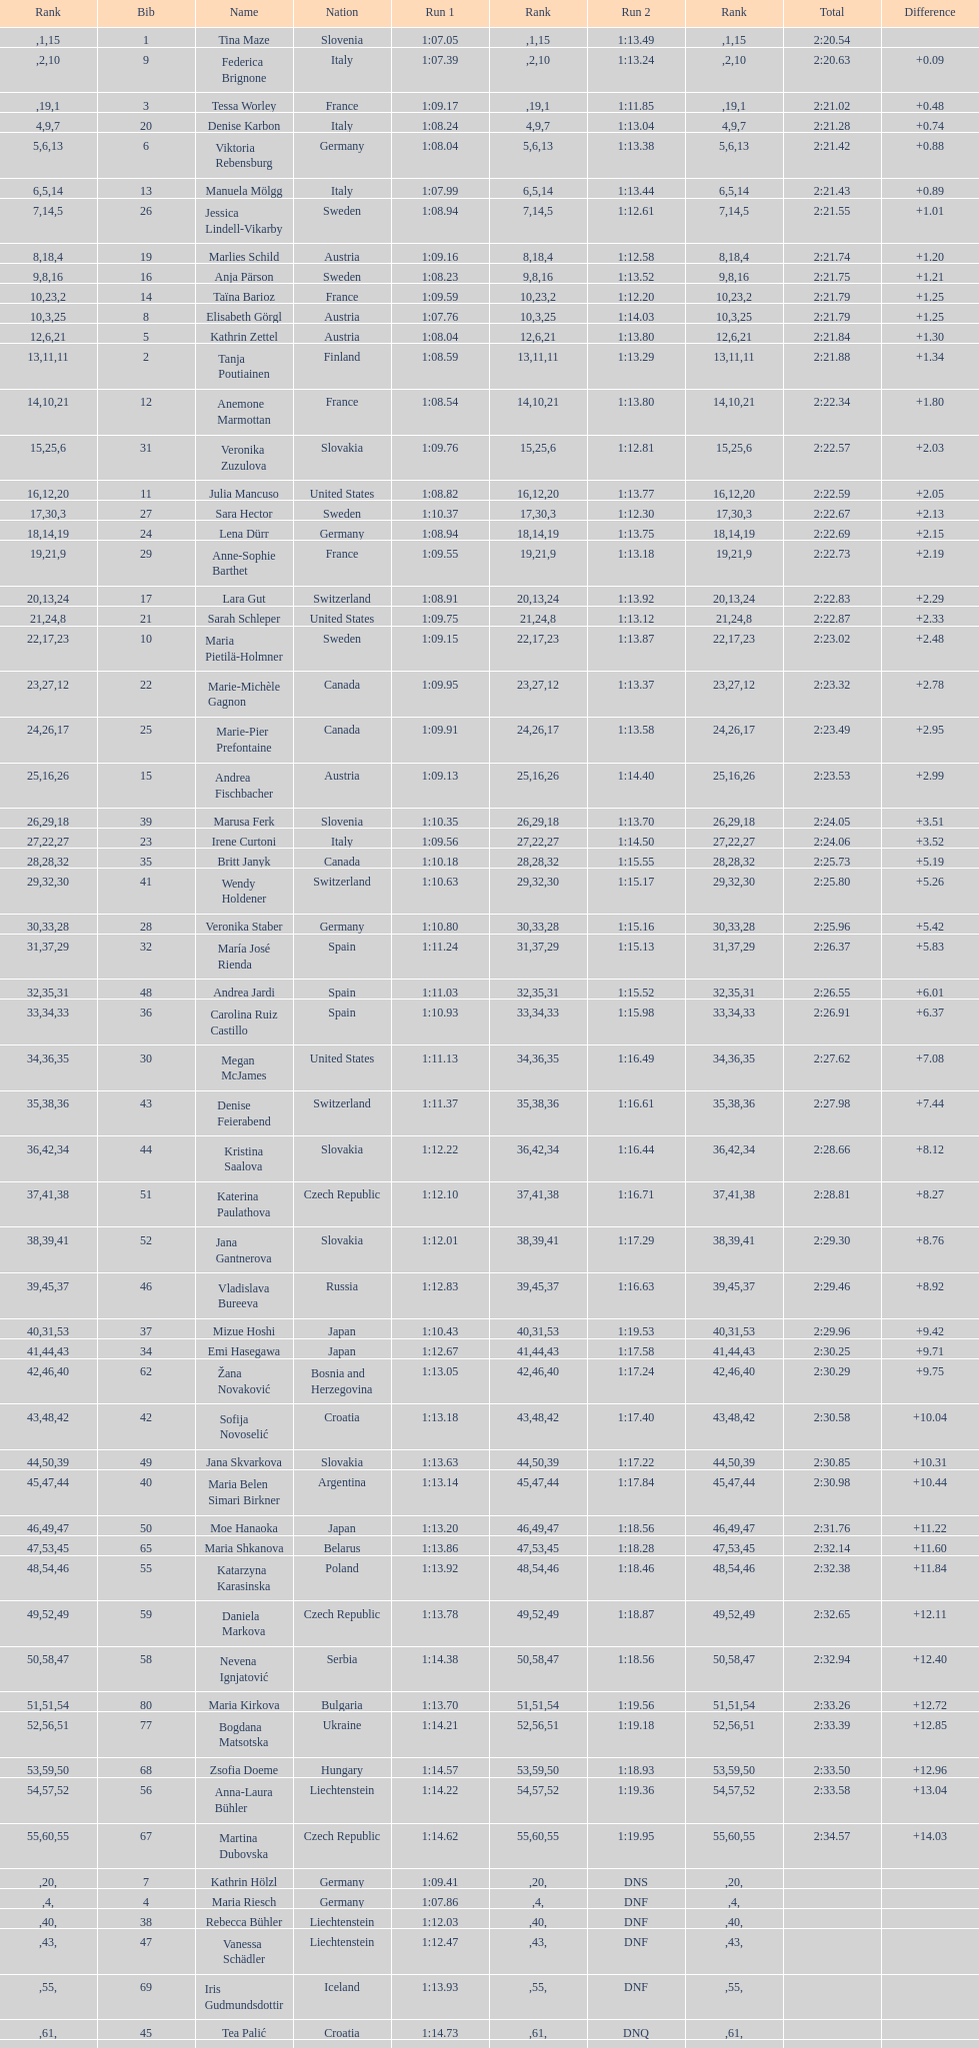What is the most recently ranked country? Czech Republic. 